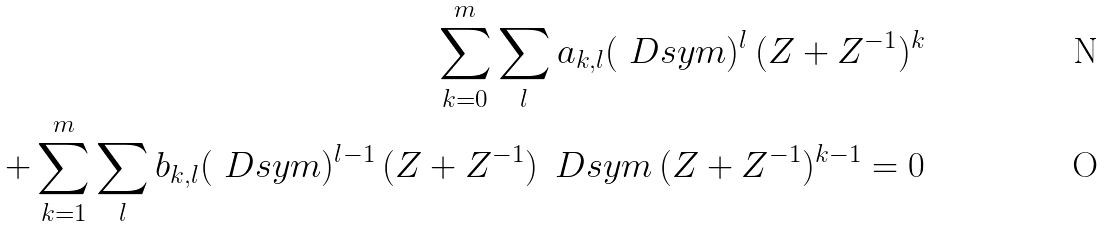Convert formula to latex. <formula><loc_0><loc_0><loc_500><loc_500>\sum _ { k = 0 } ^ { m } \sum _ { l } a _ { k , l } ( \ D s y m ) ^ { l } \, ( Z + Z ^ { - 1 } ) ^ { k } \\ + \sum _ { k = 1 } ^ { m } \sum _ { l } b _ { k , l } ( \ D s y m ) ^ { l - 1 } \, ( Z + Z ^ { - 1 } ) \, \ D s y m \, ( Z + Z ^ { - 1 } ) ^ { k - 1 } = 0</formula> 